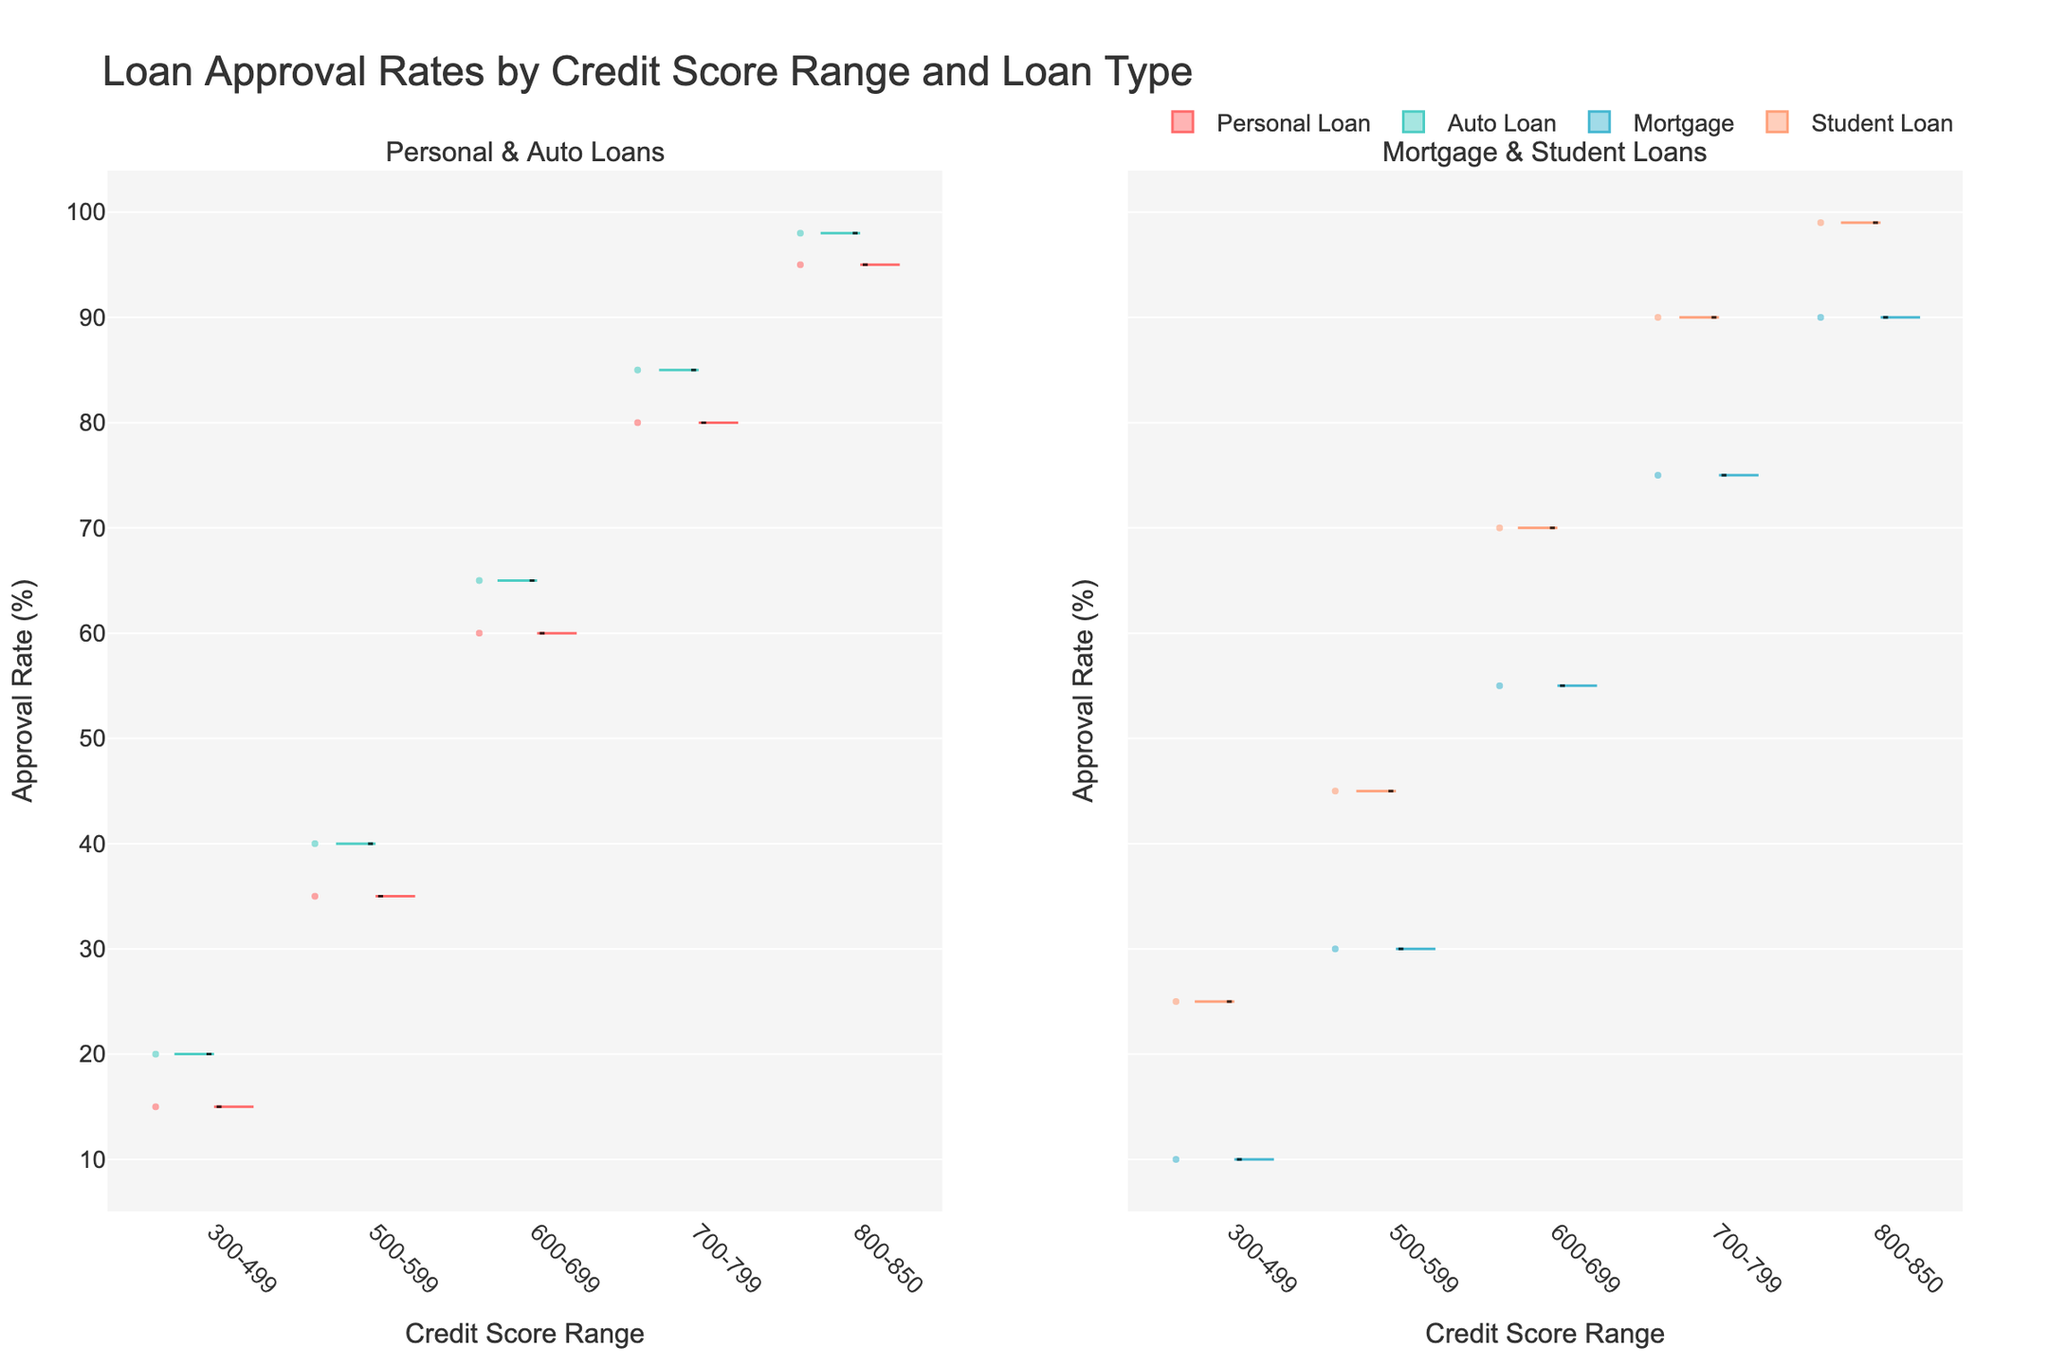What is the title of the figure? The title is prominently displayed at the top of the figure, indicating its main subject matter.
Answer: Loan Approval Rates by Credit Score Range and Loan Type Which loan type shows the highest approval rate for the 800-850 credit score range? Looking at the split violins, the Student Loan type exceeds 95% in the 800-850 range.
Answer: Student Loan How many credit score ranges are represented in the figure? Count the number of different categories on the x-axis under the title "Credit Score Range".
Answer: 5 Which subplot shows approval rates for Mortgage loans? The subplots are titled, and the Mortgage loan category is named in the second subplot.
Answer: The right subplot Among Personal and Auto loans, which loan type has a generally higher approval rate for the 300-499 credit score range? Compare the heights of the violins in the 300-499 range for Personal and Auto loans.
Answer: Auto Loan In the 600-699 credit score range, what is the difference in approval rates between Personal and Auto loans? Find the y-values for both loan types in the 600-699 range and subtract them.
Answer: 5% Between Personal Loan and Mortgage, which loan type has a higher mean approval rate in the 500-599 credit score range? Locate the mean lines for both loan types in the given range and compare their positions.
Answer: Personal Loan Which loan type among Auto Loan and Student Loan has more variation in approval rates for the 700-799 range? Check the spread of the violin plots in the 700-799 range to determine which has a broader spread.
Answer: Student Loan Are the mean and median approval rates for Personal Loan in the 800-850 credit score range the same or different? Analyze the positions of the mean line and box center within the violin for the 800-850 range.
Answer: Different What is the overall trend of approval rates as credit scores increase from 300 to 850? Observe the overall direction of the violin plots as they move from left (300-499) to right (800-850).
Answer: Increasing 